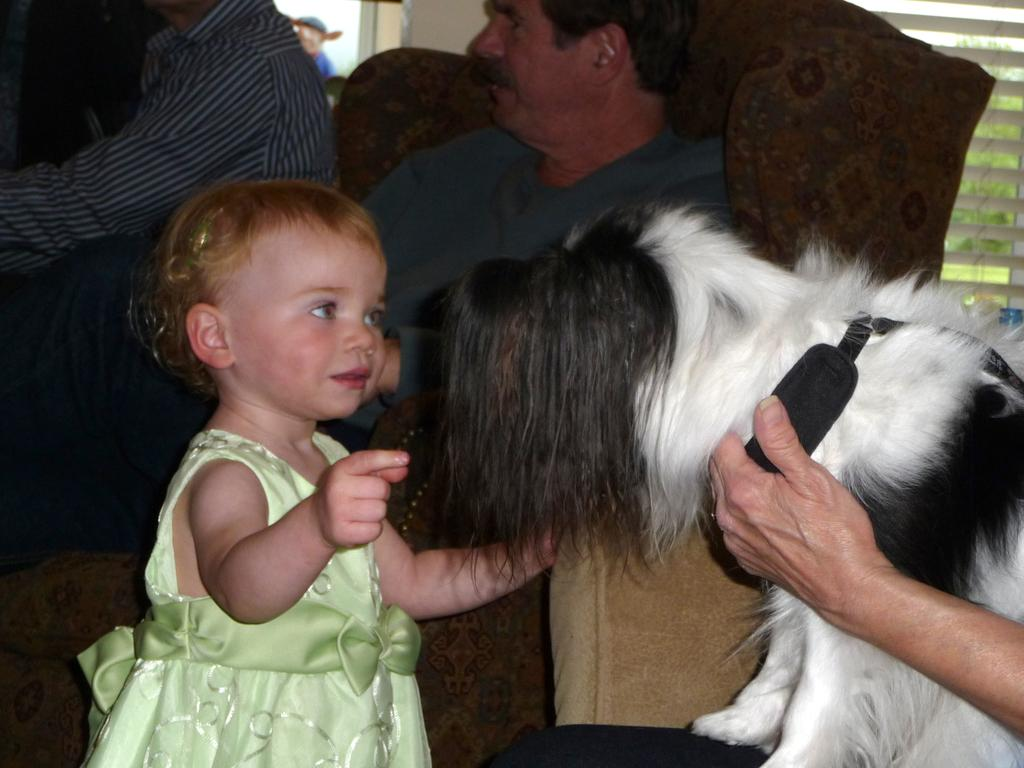Who is the main subject in the image? The main subject in the image is a baby girl. What is the baby girl looking at? The baby girl is looking at a dog. Where is the dog located in the image? The dog is on the lap of a man. Can you describe the setting in the background? There is a man sitting on a sofa in the background. What type of shoes is the baby girl wearing in the image? The baby girl is not wearing any shoes in the image. How is the distribution of toys in the room being managed in the image? There is no mention of toys in the image, so we cannot determine how their distribution is being managed. 